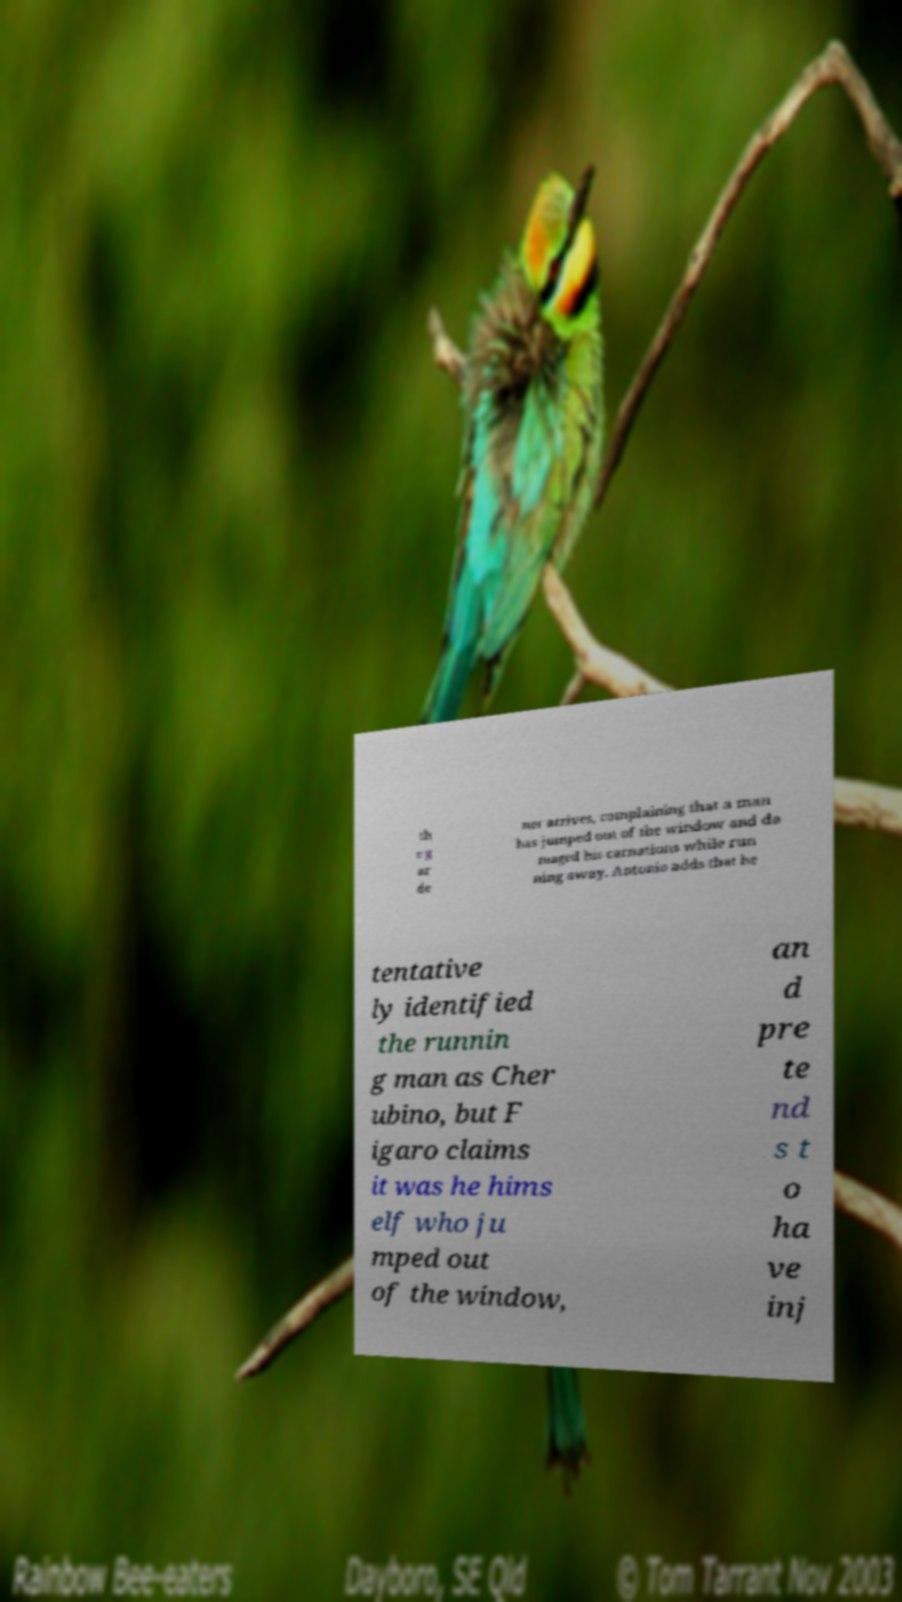Can you read and provide the text displayed in the image?This photo seems to have some interesting text. Can you extract and type it out for me? th e g ar de ner arrives, complaining that a man has jumped out of the window and da maged his carnations while run ning away. Antonio adds that he tentative ly identified the runnin g man as Cher ubino, but F igaro claims it was he hims elf who ju mped out of the window, an d pre te nd s t o ha ve inj 